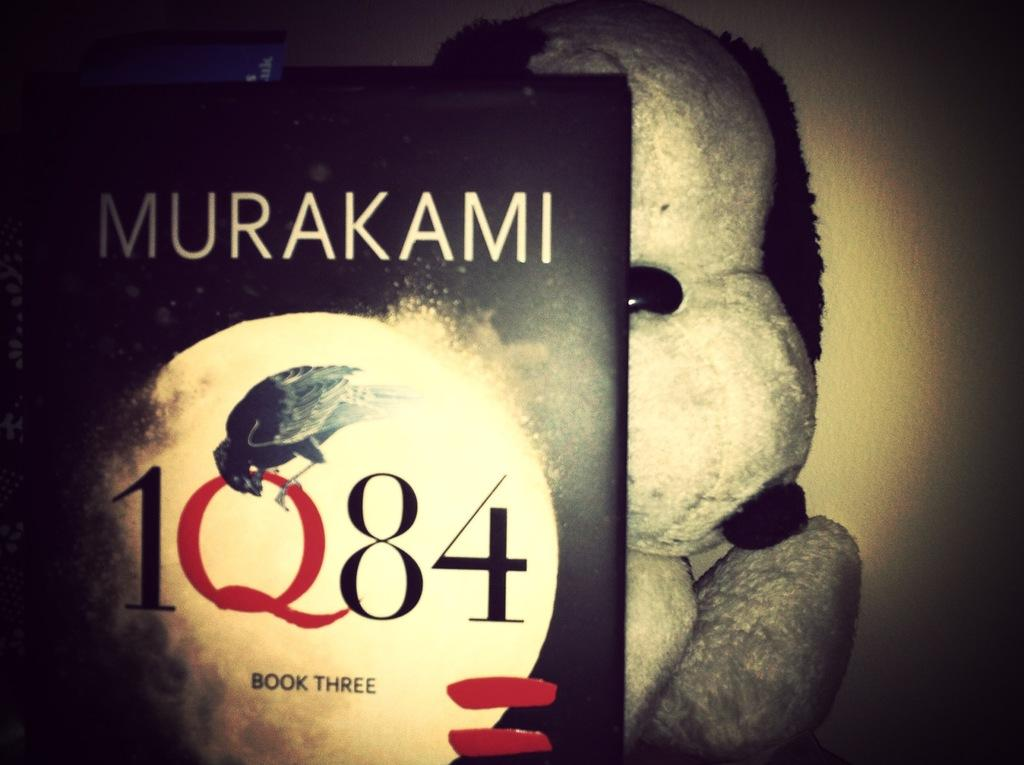Provide a one-sentence caption for the provided image. book three of 1Q84 with a black cover. 